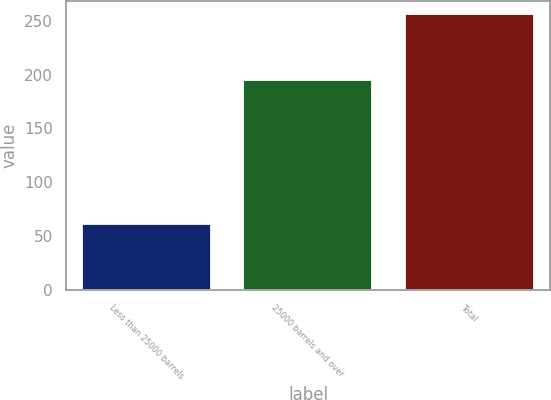Convert chart. <chart><loc_0><loc_0><loc_500><loc_500><bar_chart><fcel>Less than 25000 barrels<fcel>25000 barrels and over<fcel>Total<nl><fcel>61<fcel>195<fcel>256<nl></chart> 